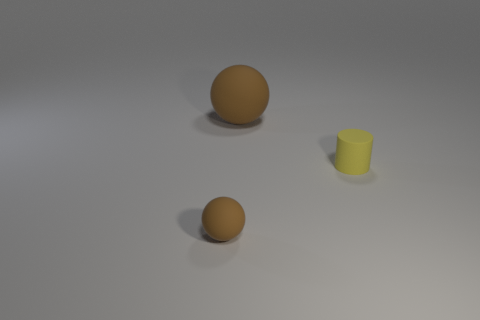What is the big sphere made of?
Give a very brief answer. Rubber. How many other things are the same shape as the small brown rubber thing?
Keep it short and to the point. 1. There is a large thing that is the same color as the tiny ball; what is its material?
Give a very brief answer. Rubber. Is there any other thing that is the same shape as the tiny yellow thing?
Ensure brevity in your answer.  No. There is a tiny rubber object behind the brown rubber object in front of the brown sphere that is on the right side of the tiny rubber ball; what color is it?
Provide a short and direct response. Yellow. What number of tiny things are either brown rubber balls or yellow cylinders?
Provide a short and direct response. 2. Are there an equal number of big brown rubber things to the left of the large brown ball and large brown cylinders?
Your answer should be very brief. Yes. There is a big rubber ball; are there any small brown matte objects in front of it?
Offer a very short reply. Yes. What number of shiny objects are either tiny yellow objects or large spheres?
Offer a very short reply. 0. There is a large brown matte sphere; how many tiny rubber cylinders are on the left side of it?
Your response must be concise. 0. 